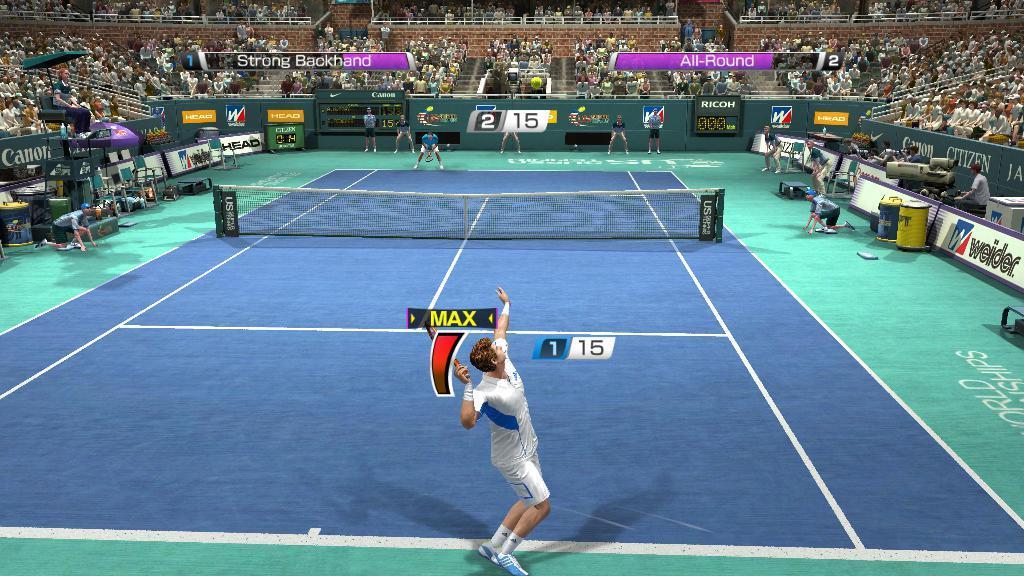In one or two sentences, can you explain what this image depicts? This is the picture of a tennis court were players are playing tennis and audience are watching by siting on the seats. The player is wearing white color t-shirt with shorts and white and blue color shoe. The court is in blue and purple in color. 